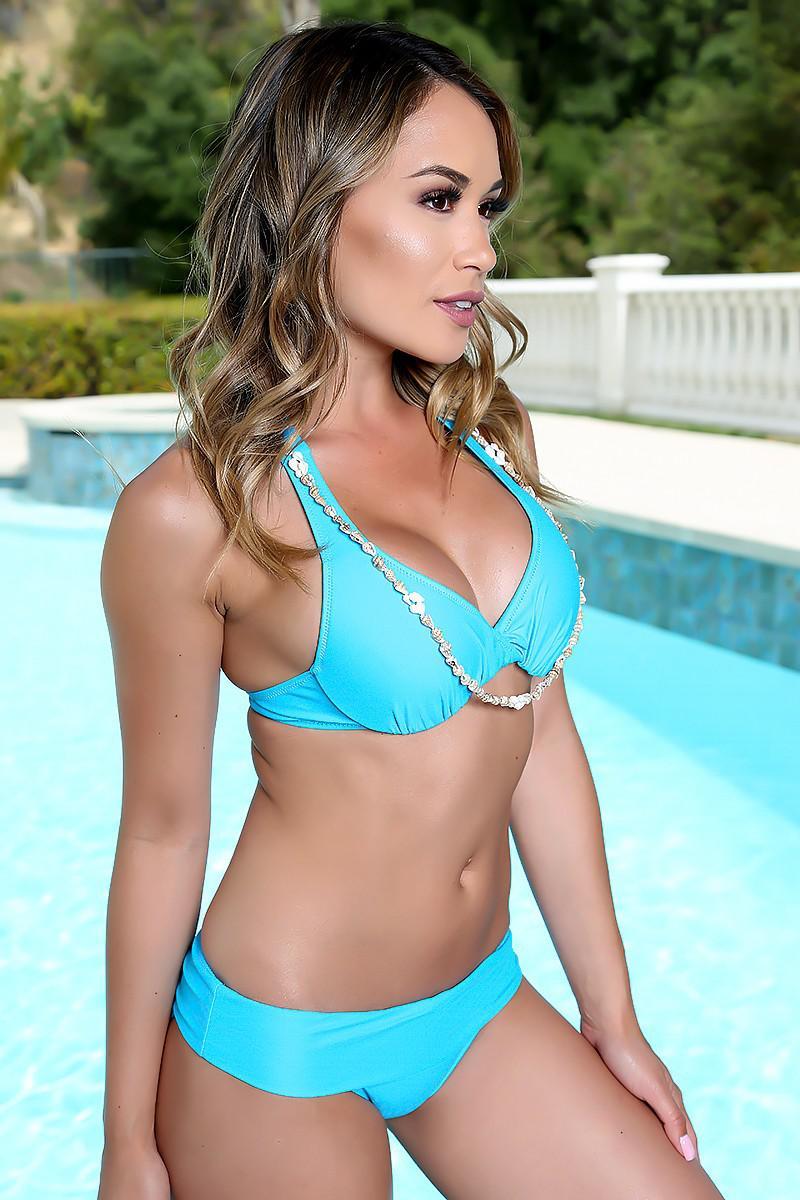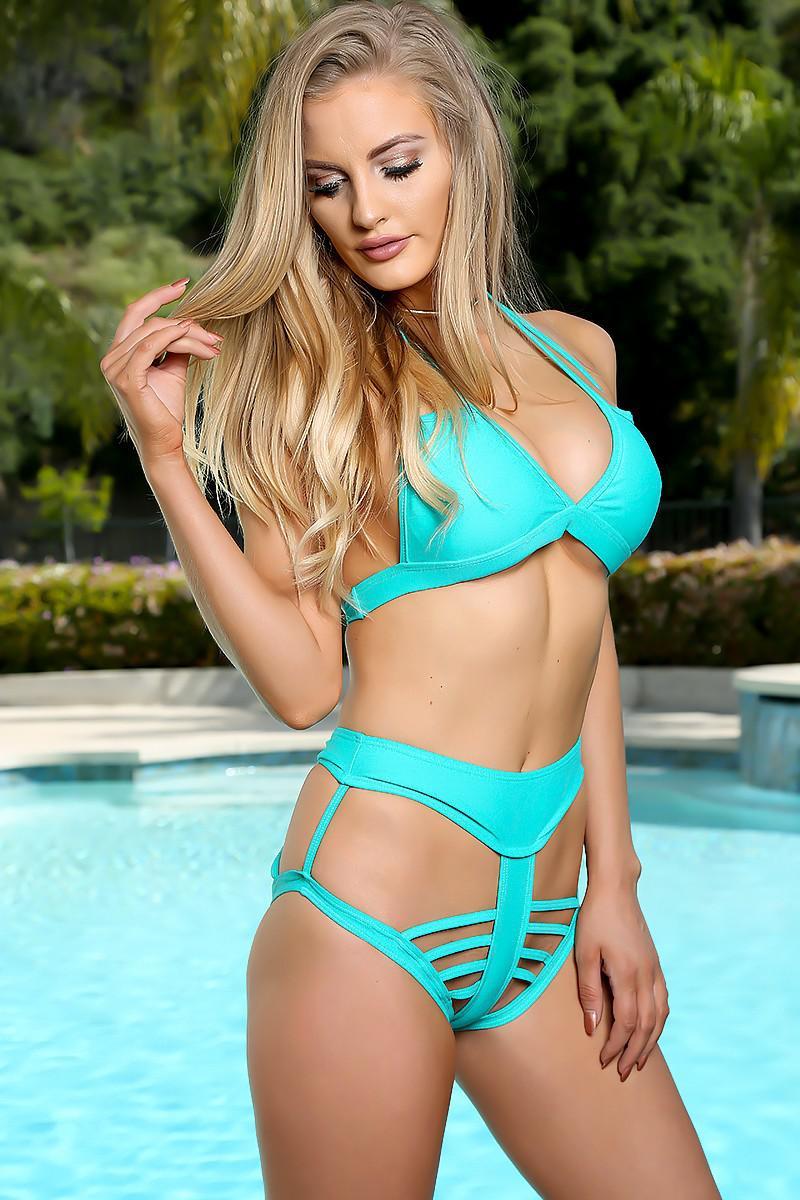The first image is the image on the left, the second image is the image on the right. Examine the images to the left and right. Is the description "At least one bikini is baby blue." accurate? Answer yes or no. Yes. The first image is the image on the left, the second image is the image on the right. Given the left and right images, does the statement "The bikini in the image on the left is tied at the hip" hold true? Answer yes or no. No. 